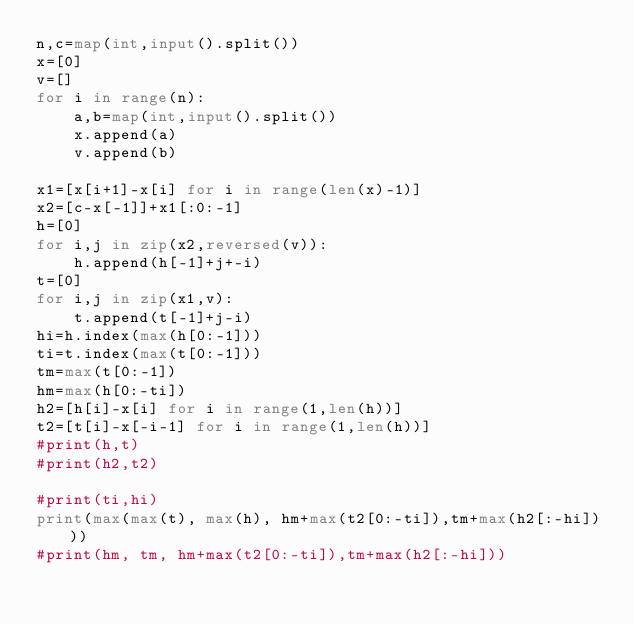<code> <loc_0><loc_0><loc_500><loc_500><_Python_>n,c=map(int,input().split())
x=[0]
v=[]
for i in range(n):
    a,b=map(int,input().split())
    x.append(a)
    v.append(b)

x1=[x[i+1]-x[i] for i in range(len(x)-1)]
x2=[c-x[-1]]+x1[:0:-1]
h=[0]
for i,j in zip(x2,reversed(v)):
    h.append(h[-1]+j+-i)
t=[0]
for i,j in zip(x1,v):
    t.append(t[-1]+j-i)
hi=h.index(max(h[0:-1]))
ti=t.index(max(t[0:-1]))
tm=max(t[0:-1])
hm=max(h[0:-ti])
h2=[h[i]-x[i] for i in range(1,len(h))]
t2=[t[i]-x[-i-1] for i in range(1,len(h))]
#print(h,t)
#print(h2,t2)

#print(ti,hi)
print(max(max(t), max(h), hm+max(t2[0:-ti]),tm+max(h2[:-hi])))
#print(hm, tm, hm+max(t2[0:-ti]),tm+max(h2[:-hi]))</code> 